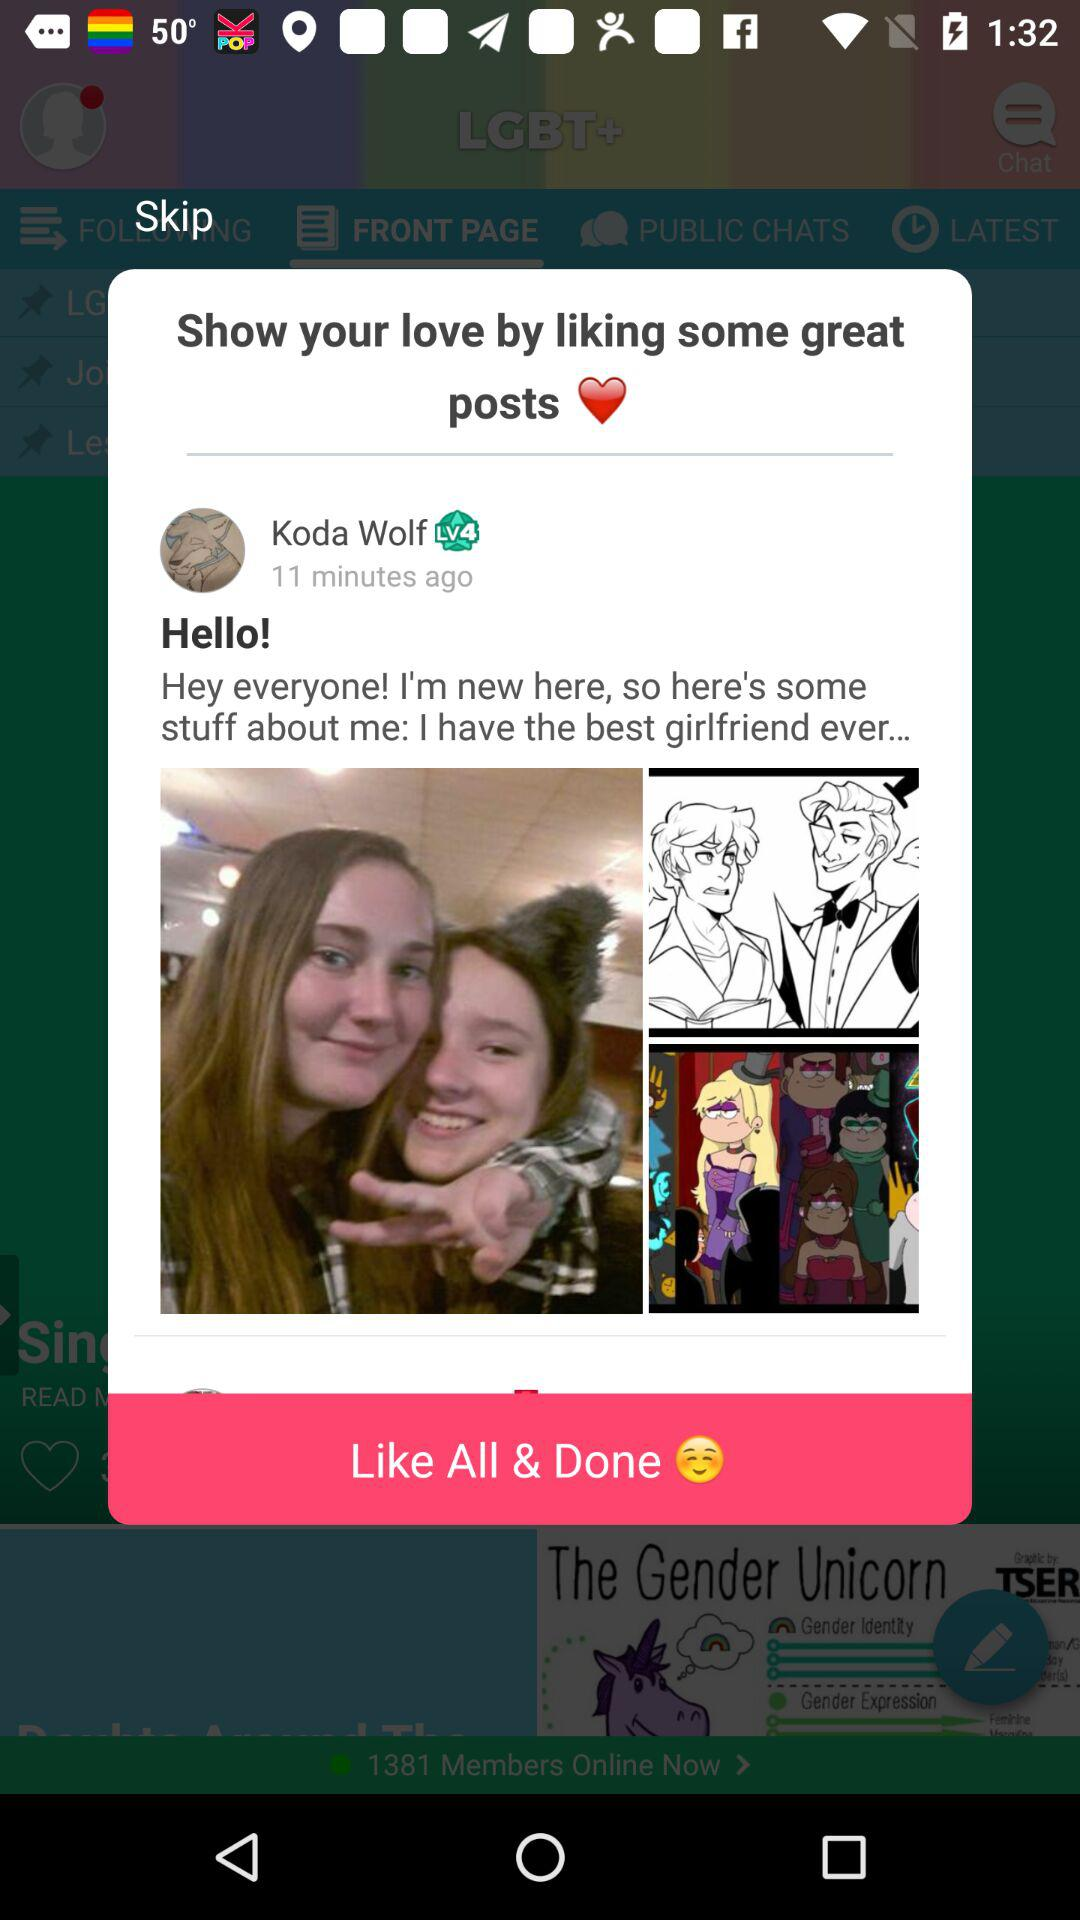What is the user name? The user name is Koda Wolf. 